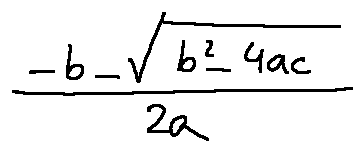<formula> <loc_0><loc_0><loc_500><loc_500>\frac { - b - \sqrt { b ^ { 2 } - 4 a c } } { 2 a }</formula> 